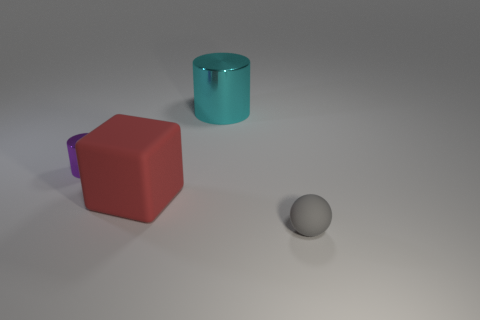Is there anything else of the same color as the rubber cube?
Ensure brevity in your answer.  No. Is there a large cyan thing left of the metallic thing that is to the right of the small object that is to the left of the sphere?
Your response must be concise. No. Does the metallic thing to the right of the small purple thing have the same color as the tiny ball?
Provide a succinct answer. No. What number of cubes are tiny purple objects or small gray shiny things?
Ensure brevity in your answer.  0. What shape is the small thing on the right side of the rubber object that is on the left side of the gray rubber thing?
Provide a short and direct response. Sphere. What size is the cylinder that is in front of the cylinder to the right of the cylinder on the left side of the big red thing?
Offer a terse response. Small. Do the block and the gray rubber ball have the same size?
Your response must be concise. No. What number of things are small gray balls or big blue shiny things?
Your answer should be very brief. 1. There is a matte object that is to the left of the metallic cylinder that is right of the matte block; what is its size?
Your response must be concise. Large. The cyan shiny cylinder is what size?
Offer a very short reply. Large. 